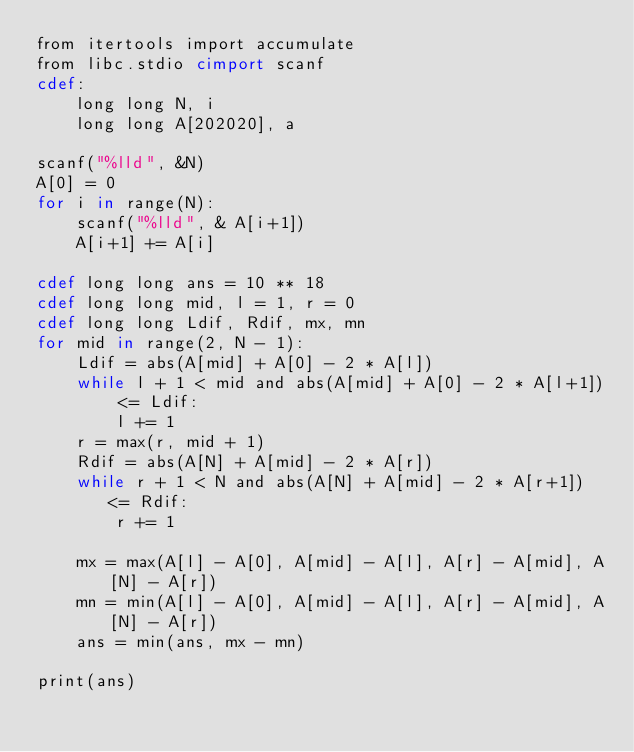Convert code to text. <code><loc_0><loc_0><loc_500><loc_500><_Cython_>from itertools import accumulate
from libc.stdio cimport scanf
cdef:
    long long N, i
    long long A[202020], a

scanf("%lld", &N)
A[0] = 0
for i in range(N):
    scanf("%lld", & A[i+1])
    A[i+1] += A[i]

cdef long long ans = 10 ** 18
cdef long long mid, l = 1, r = 0
cdef long long Ldif, Rdif, mx, mn
for mid in range(2, N - 1):
    Ldif = abs(A[mid] + A[0] - 2 * A[l])
    while l + 1 < mid and abs(A[mid] + A[0] - 2 * A[l+1]) <= Ldif:
        l += 1
    r = max(r, mid + 1)
    Rdif = abs(A[N] + A[mid] - 2 * A[r])
    while r + 1 < N and abs(A[N] + A[mid] - 2 * A[r+1]) <= Rdif:
        r += 1

    mx = max(A[l] - A[0], A[mid] - A[l], A[r] - A[mid], A[N] - A[r])
    mn = min(A[l] - A[0], A[mid] - A[l], A[r] - A[mid], A[N] - A[r])
    ans = min(ans, mx - mn)

print(ans)</code> 